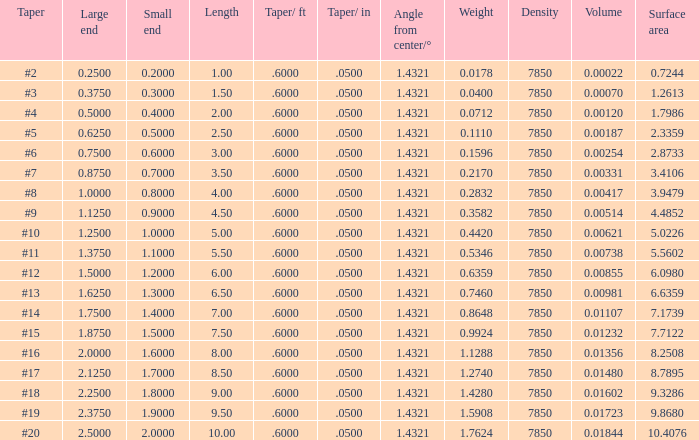Which Length has a Taper of #15, and a Large end larger than 1.875? None. 